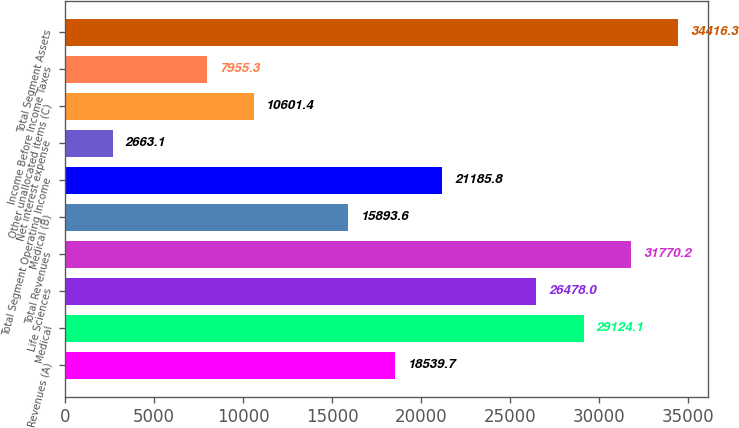<chart> <loc_0><loc_0><loc_500><loc_500><bar_chart><fcel>Revenues (A)<fcel>Medical<fcel>Life Sciences<fcel>Total Revenues<fcel>Medical (B)<fcel>Total Segment Operating Income<fcel>Net interest expense<fcel>Other unallocated items (C)<fcel>Income Before Income Taxes<fcel>Total Segment Assets<nl><fcel>18539.7<fcel>29124.1<fcel>26478<fcel>31770.2<fcel>15893.6<fcel>21185.8<fcel>2663.1<fcel>10601.4<fcel>7955.3<fcel>34416.3<nl></chart> 